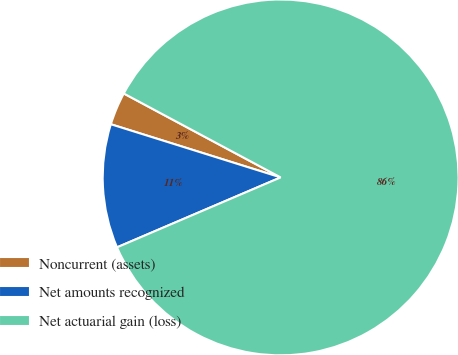Convert chart. <chart><loc_0><loc_0><loc_500><loc_500><pie_chart><fcel>Noncurrent (assets)<fcel>Net amounts recognized<fcel>Net actuarial gain (loss)<nl><fcel>2.99%<fcel>11.26%<fcel>85.75%<nl></chart> 